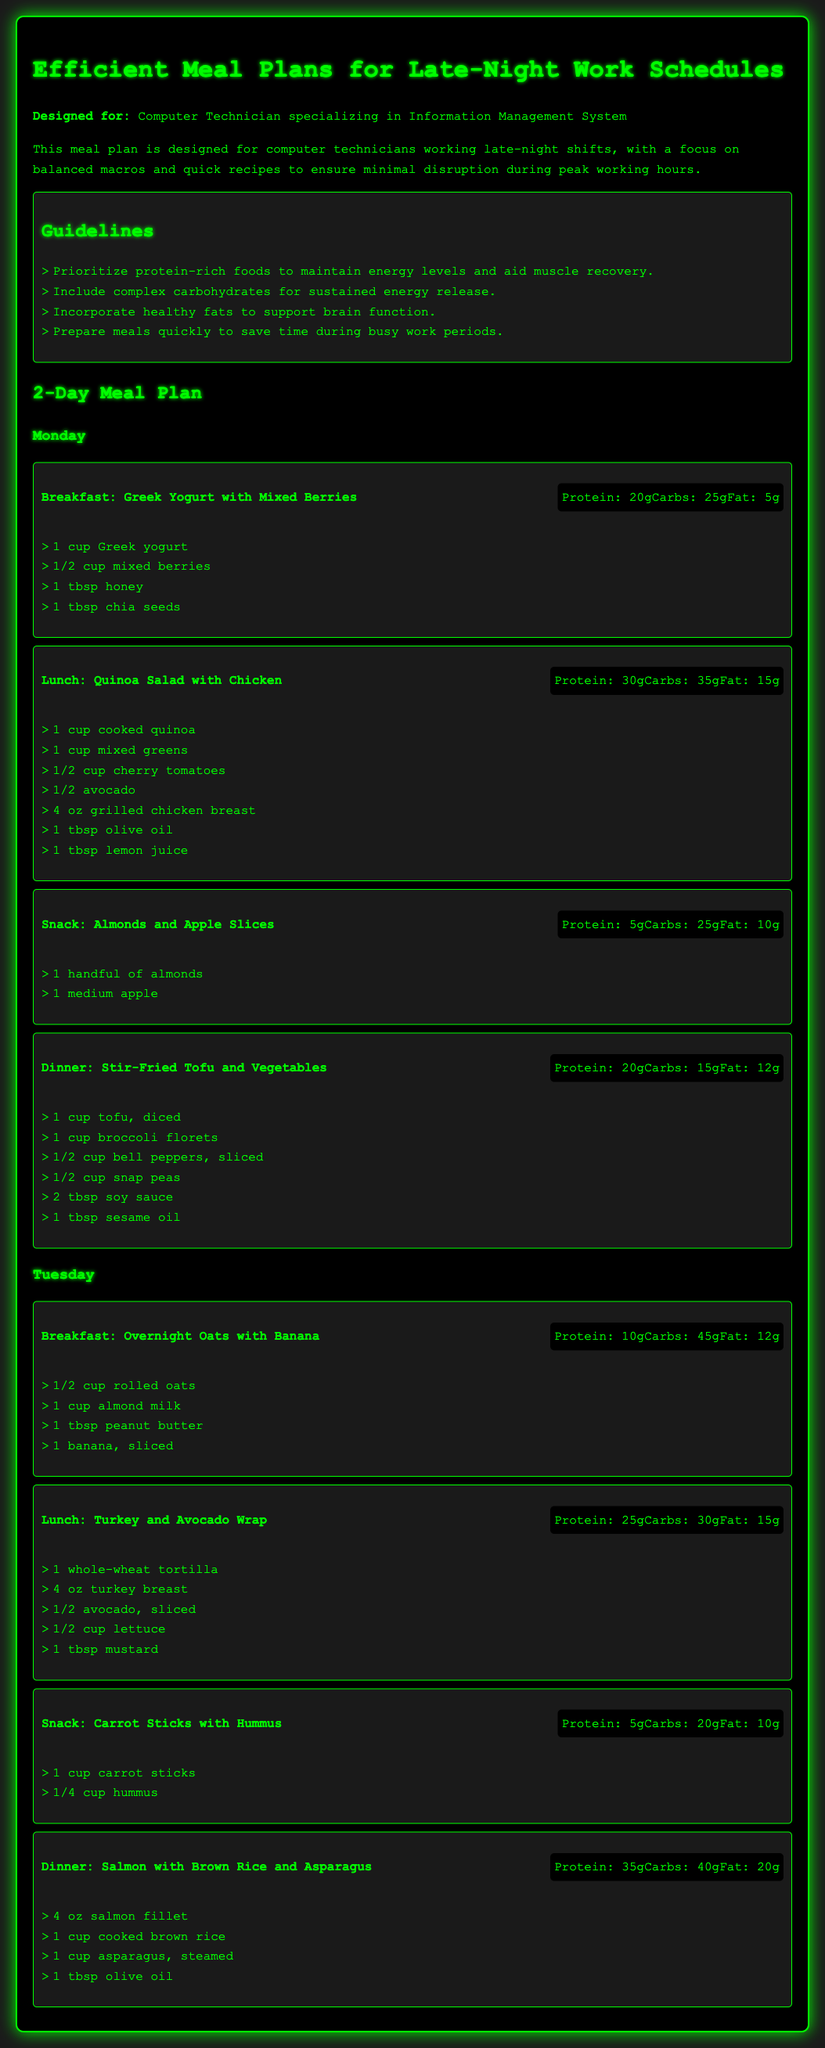What is the main target audience of the meal plan? The meal plan is designed specifically for computer technicians working late-night shifts.
Answer: computer technicians How many grams of protein are in the stir-fried tofu and vegetables dinner? The protein content for stir-fried tofu and vegetables is stated in the meal section, which is 20 grams.
Answer: 20g What is one of the guidelines mentioned for the meal plan? The guidelines include several points, and one of them suggests to include complex carbohydrates for sustained energy release.
Answer: include complex carbohydrates What type of meal is listed first for Monday? The first meal listed for Monday is breakfast, specifically Greek yogurt with mixed berries.
Answer: Breakfast: Greek Yogurt with Mixed Berries What is the total carbohydrate content for the lunch on Tuesday? The carbohydrate content for the Turkey and Avocado Wrap lunch on Tuesday is mentioned as 30 grams.
Answer: 30g How long is the meal plan designed for? The meal plan covers two days, specifically Monday and Tuesday.
Answer: 2 days What is included in the snack for Monday? The snack listed for Monday consists of almonds and apple slices.
Answer: Almonds and Apple Slices What is the macronutrient breakdown of the salmon dinner? The macronutrient breakdown for the salmon dinner is provided in the document, showing 35 grams of protein, 40 grams of carbohydrates, and 20 grams of fat.
Answer: Protein: 35g, Carbs: 40g, Fat: 20g 